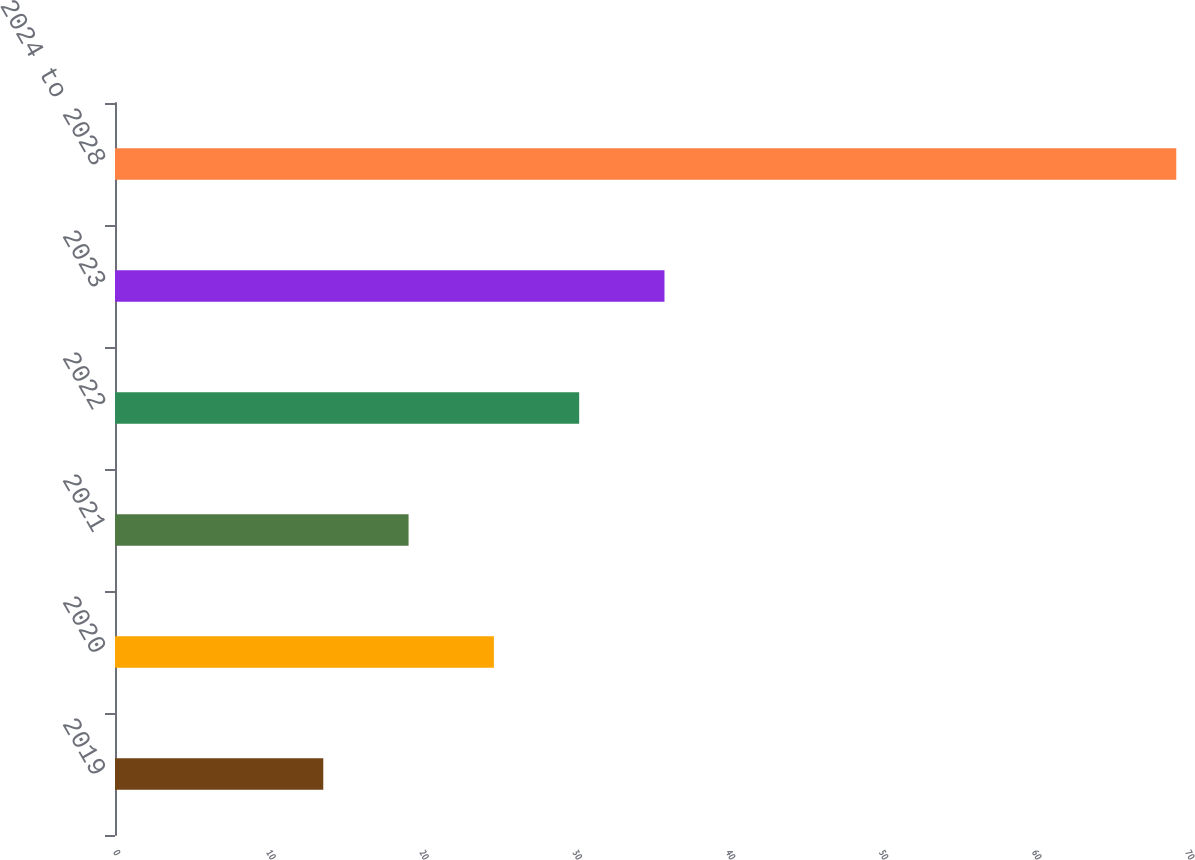<chart> <loc_0><loc_0><loc_500><loc_500><bar_chart><fcel>2019<fcel>2020<fcel>2021<fcel>2022<fcel>2023<fcel>2024 to 2028<nl><fcel>13.6<fcel>24.74<fcel>19.17<fcel>30.31<fcel>35.88<fcel>69.3<nl></chart> 